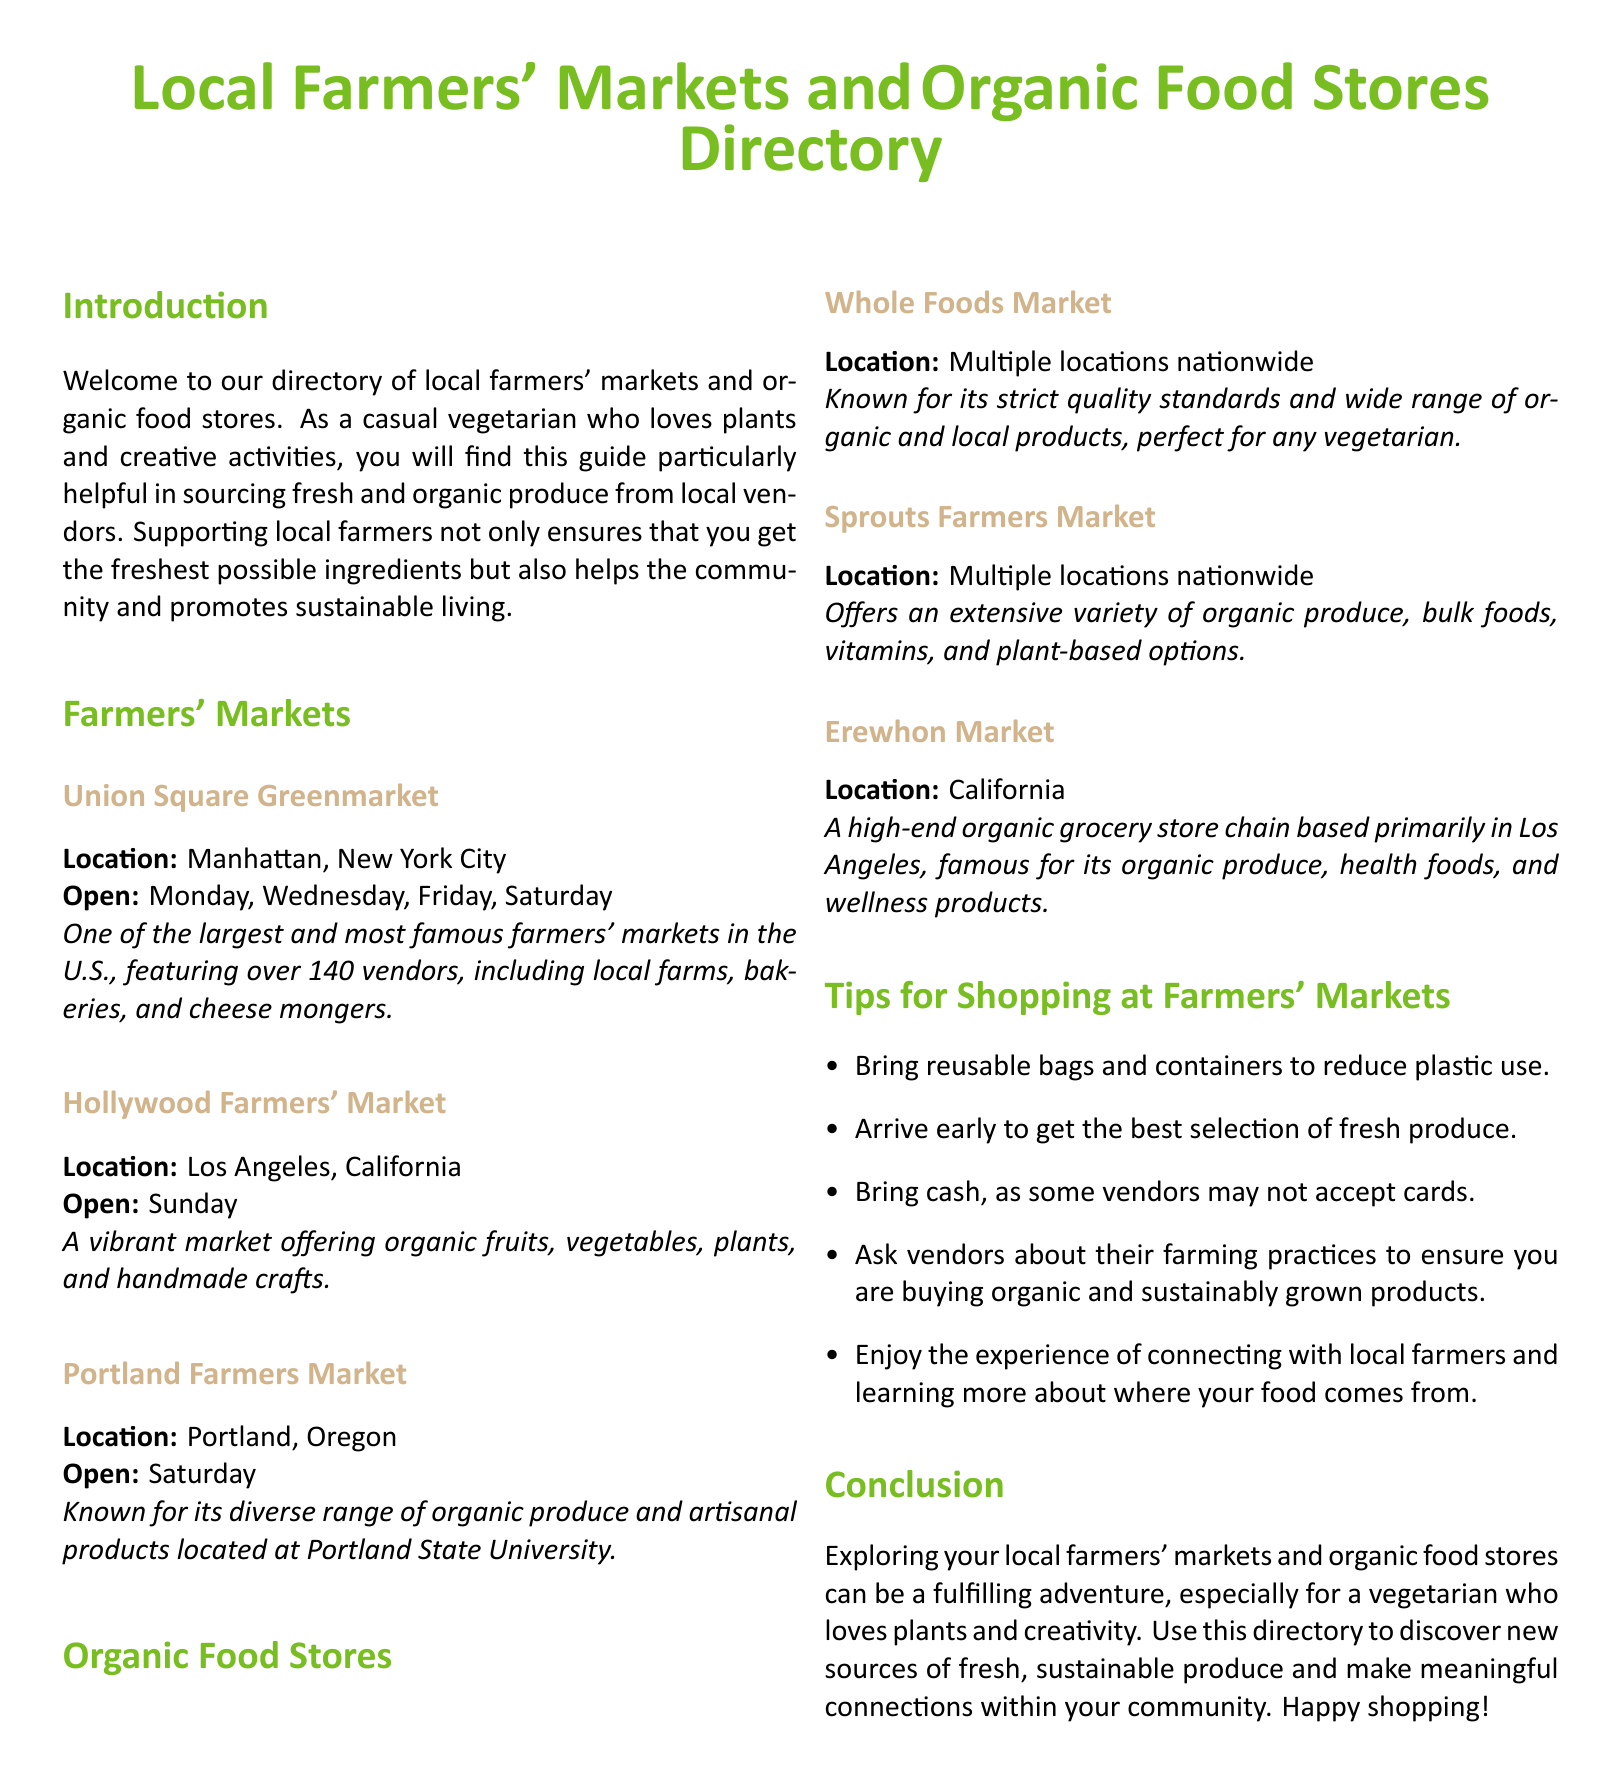What is the location of the Union Square Greenmarket? The Union Square Greenmarket is located in Manhattan, New York City.
Answer: Manhattan, New York City What day is the Hollywood Farmers' Market open? The Hollywood Farmers' Market is open on Sunday.
Answer: Sunday How many vendors are at the Union Square Greenmarket? The document states that the Union Square Greenmarket features over 140 vendors.
Answer: Over 140 What type of products does Whole Foods Market offer? Whole Foods Market is known for its wide range of organic and local products.
Answer: Organic and local products Which farmers' market is located at Portland State University? The Portland Farmers Market is known for being located at Portland State University.
Answer: Portland Farmers Market What is a tip for shopping at farmers' markets? One tip is to bring reusable bags and containers to reduce plastic use.
Answer: Bring reusable bags What type of store is Erewhon Market? Erewhon Market is described as a high-end organic grocery store chain.
Answer: High-end organic grocery store chain What should customers do to ensure they are buying sustainably grown products? Customers should ask vendors about their farming practices.
Answer: Ask vendors about their farming practices What is one benefit of supporting local farmers? Supporting local farmers helps the community and promotes sustainable living.
Answer: Helps the community and promotes sustainable living 